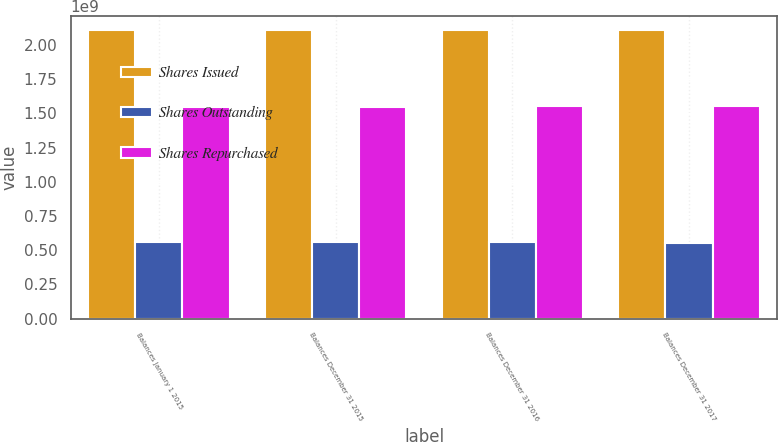<chart> <loc_0><loc_0><loc_500><loc_500><stacked_bar_chart><ecel><fcel>Balances January 1 2015<fcel>Balances December 31 2015<fcel>Balances December 31 2016<fcel>Balances December 31 2017<nl><fcel>Shares Issued<fcel>2.10932e+09<fcel>2.10932e+09<fcel>2.10932e+09<fcel>2.10932e+09<nl><fcel>Shares Outstanding<fcel>5.62417e+08<fcel>5.59972e+08<fcel>5.57931e+08<fcel>5.56099e+08<nl><fcel>Shares Repurchased<fcel>1.5469e+09<fcel>1.54934e+09<fcel>1.55139e+09<fcel>1.55322e+09<nl></chart> 